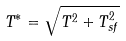Convert formula to latex. <formula><loc_0><loc_0><loc_500><loc_500>T ^ { * } = \sqrt { T ^ { 2 } + T _ { s f } ^ { 2 } }</formula> 